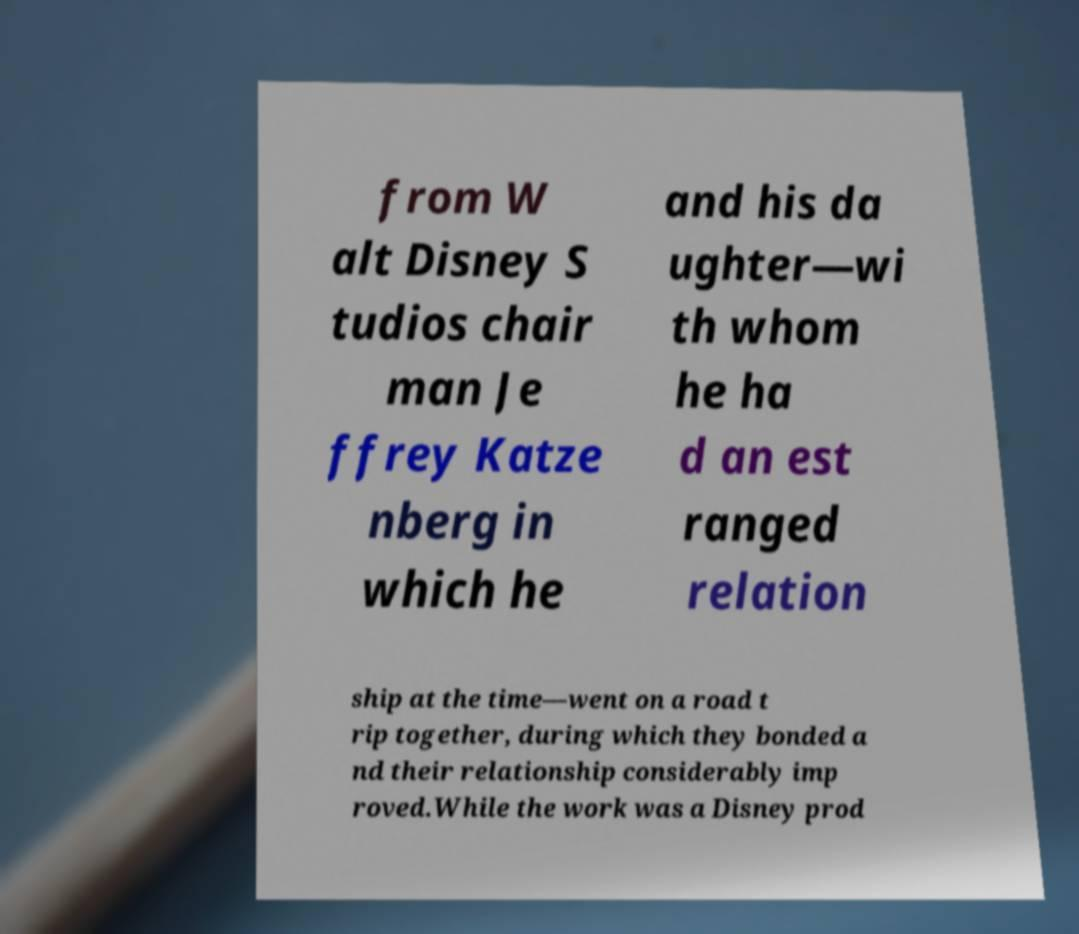There's text embedded in this image that I need extracted. Can you transcribe it verbatim? from W alt Disney S tudios chair man Je ffrey Katze nberg in which he and his da ughter—wi th whom he ha d an est ranged relation ship at the time—went on a road t rip together, during which they bonded a nd their relationship considerably imp roved.While the work was a Disney prod 